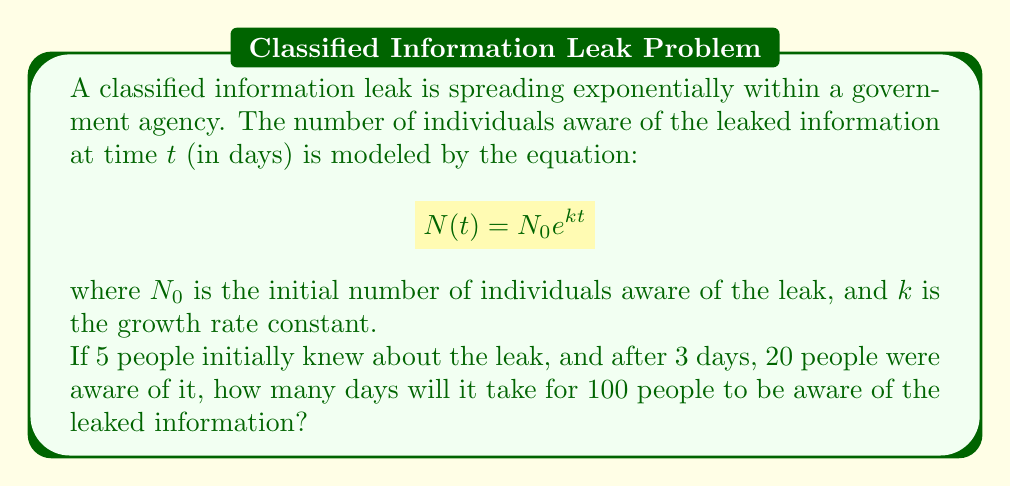What is the answer to this math problem? Let's approach this step-by-step:

1) We're given that $N_0 = 5$ (initial number of people aware)

2) We know that after 3 days, 20 people were aware. We can use this to find $k$:

   $$20 = 5e^{3k}$$

3) Divide both sides by 5:

   $$4 = e^{3k}$$

4) Take the natural log of both sides:

   $$\ln(4) = 3k$$

5) Solve for $k$:

   $$k = \frac{\ln(4)}{3} \approx 0.4621$$

6) Now that we have $k$, we can use the original equation to find when 100 people will be aware:

   $$100 = 5e^{0.4621t}$$

7) Divide both sides by 5:

   $$20 = e^{0.4621t}$$

8) Take the natural log of both sides:

   $$\ln(20) = 0.4621t$$

9) Solve for $t$:

   $$t = \frac{\ln(20)}{0.4621} \approx 6.46$$

Therefore, it will take approximately 6.46 days for 100 people to be aware of the leaked information.
Answer: 6.46 days 